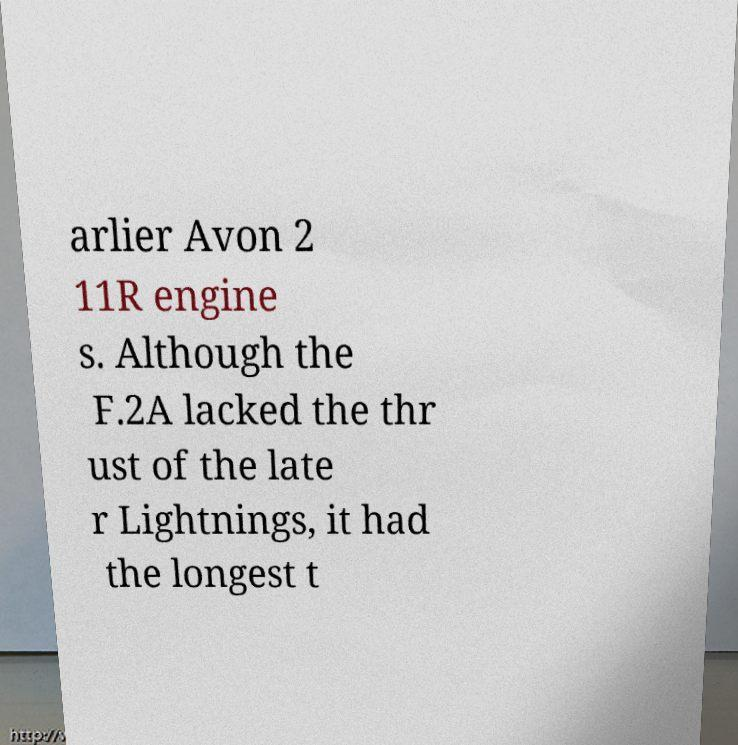Can you accurately transcribe the text from the provided image for me? arlier Avon 2 11R engine s. Although the F.2A lacked the thr ust of the late r Lightnings, it had the longest t 